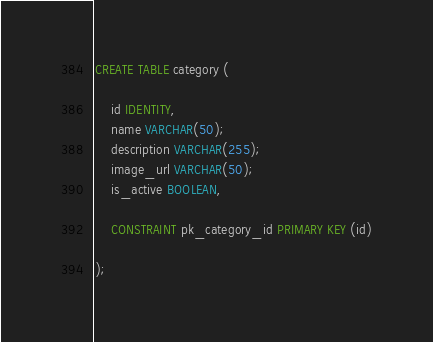<code> <loc_0><loc_0><loc_500><loc_500><_SQL_>CREATE TABLE category (
	
	id IDENTITY,
	name VARCHAR(50);
	description VARCHAR(255);
	image_url VARCHAR(50);
	is_active BOOLEAN,
	
	CONSTRAINT pk_category_id PRIMARY KEY (id)

);</code> 